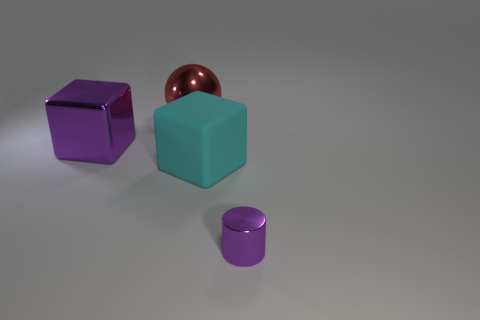Is there anything else that is the same size as the cylinder?
Provide a succinct answer. No. What number of metal things are either red balls or big things?
Your answer should be compact. 2. How many purple metal cylinders are there?
Provide a succinct answer. 1. What color is the rubber block that is the same size as the purple shiny block?
Offer a very short reply. Cyan. Does the metallic ball have the same size as the purple shiny cylinder?
Give a very brief answer. No. What is the shape of the big object that is the same color as the cylinder?
Give a very brief answer. Cube. Is the size of the red shiny ball the same as the cube to the left of the cyan object?
Provide a short and direct response. Yes. What is the color of the thing that is to the right of the sphere and behind the metallic cylinder?
Your answer should be very brief. Cyan. Are there more tiny purple cylinders that are behind the large metal ball than red shiny objects in front of the small purple cylinder?
Offer a very short reply. No. There is a purple cylinder that is the same material as the big red ball; what is its size?
Offer a terse response. Small. 